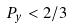<formula> <loc_0><loc_0><loc_500><loc_500>P _ { y } < 2 / 3</formula> 